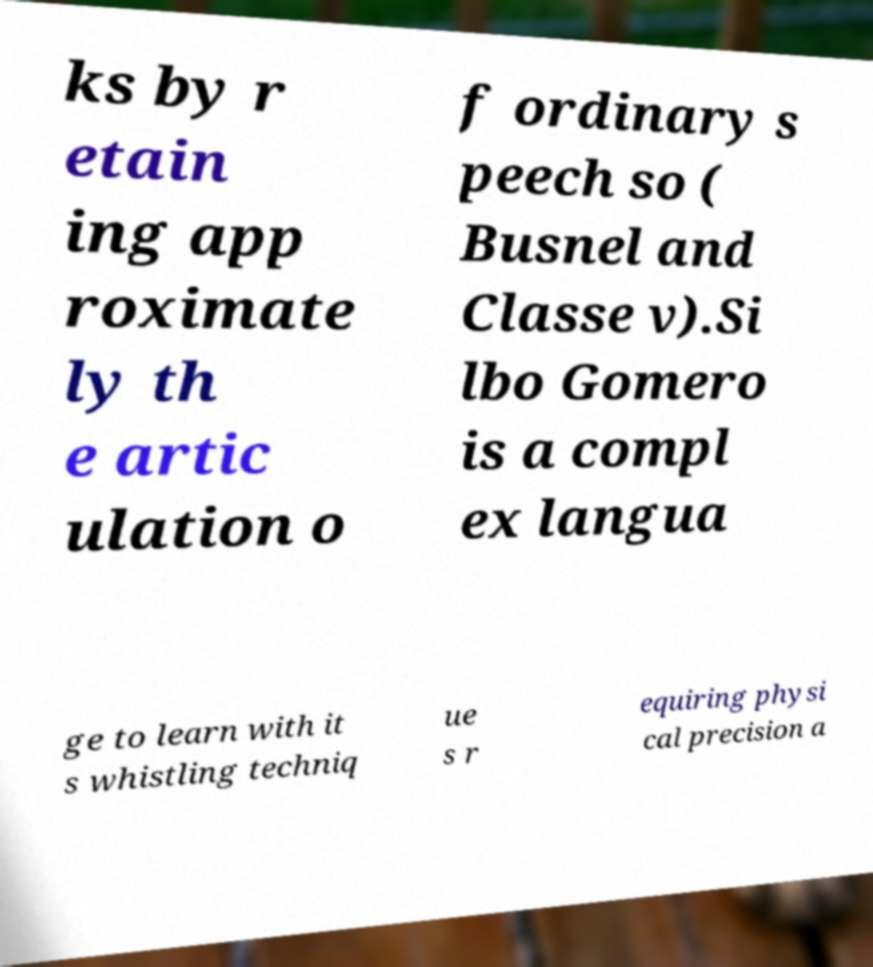There's text embedded in this image that I need extracted. Can you transcribe it verbatim? ks by r etain ing app roximate ly th e artic ulation o f ordinary s peech so ( Busnel and Classe v).Si lbo Gomero is a compl ex langua ge to learn with it s whistling techniq ue s r equiring physi cal precision a 